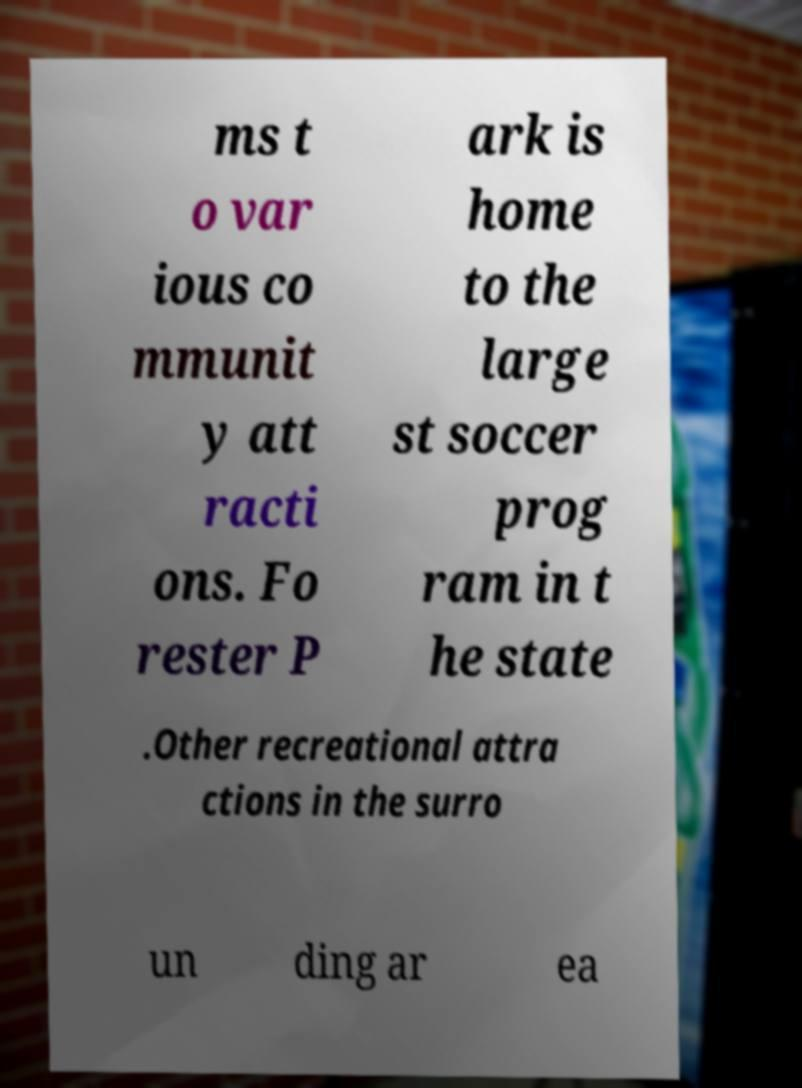Can you accurately transcribe the text from the provided image for me? ms t o var ious co mmunit y att racti ons. Fo rester P ark is home to the large st soccer prog ram in t he state .Other recreational attra ctions in the surro un ding ar ea 